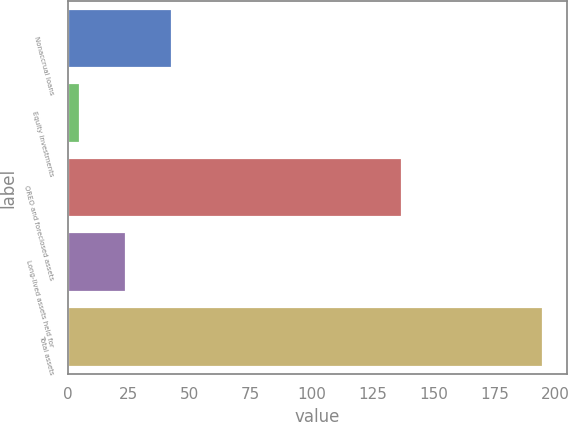Convert chart to OTSL. <chart><loc_0><loc_0><loc_500><loc_500><bar_chart><fcel>Nonaccrual loans<fcel>Equity investments<fcel>OREO and foreclosed assets<fcel>Long-lived assets held for<fcel>Total assets<nl><fcel>43<fcel>5<fcel>137<fcel>24<fcel>195<nl></chart> 